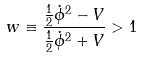Convert formula to latex. <formula><loc_0><loc_0><loc_500><loc_500>w \equiv \frac { \frac { 1 } { 2 } \dot { \phi } ^ { 2 } - V } { \frac { 1 } { 2 } \dot { \phi } ^ { 2 } + V } > 1</formula> 